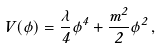<formula> <loc_0><loc_0><loc_500><loc_500>V ( \phi ) = \frac { \lambda } { 4 } \phi ^ { 4 } + \frac { m ^ { 2 } } { 2 } \phi ^ { 2 } \, ,</formula> 